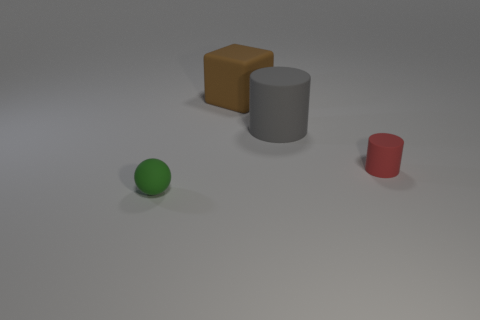Add 3 big metal cylinders. How many objects exist? 7 Subtract all balls. How many objects are left? 3 Add 3 gray cylinders. How many gray cylinders are left? 4 Add 1 gray matte cylinders. How many gray matte cylinders exist? 2 Subtract 1 brown cubes. How many objects are left? 3 Subtract all brown matte things. Subtract all rubber balls. How many objects are left? 2 